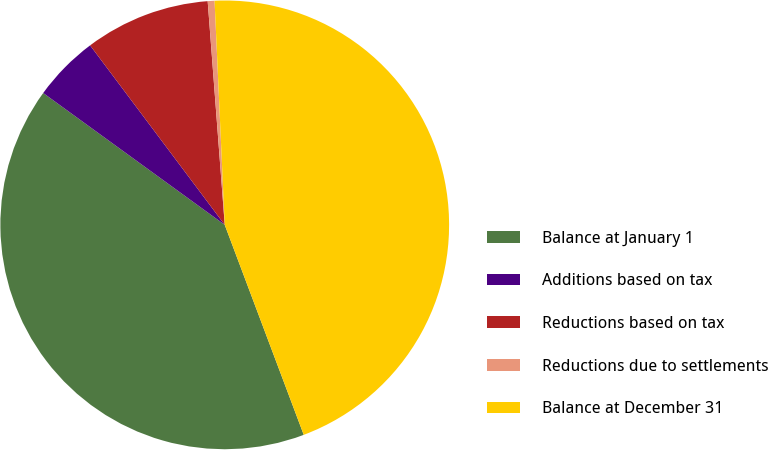Convert chart to OTSL. <chart><loc_0><loc_0><loc_500><loc_500><pie_chart><fcel>Balance at January 1<fcel>Additions based on tax<fcel>Reductions based on tax<fcel>Reductions due to settlements<fcel>Balance at December 31<nl><fcel>40.72%<fcel>4.76%<fcel>9.03%<fcel>0.49%<fcel>44.99%<nl></chart> 